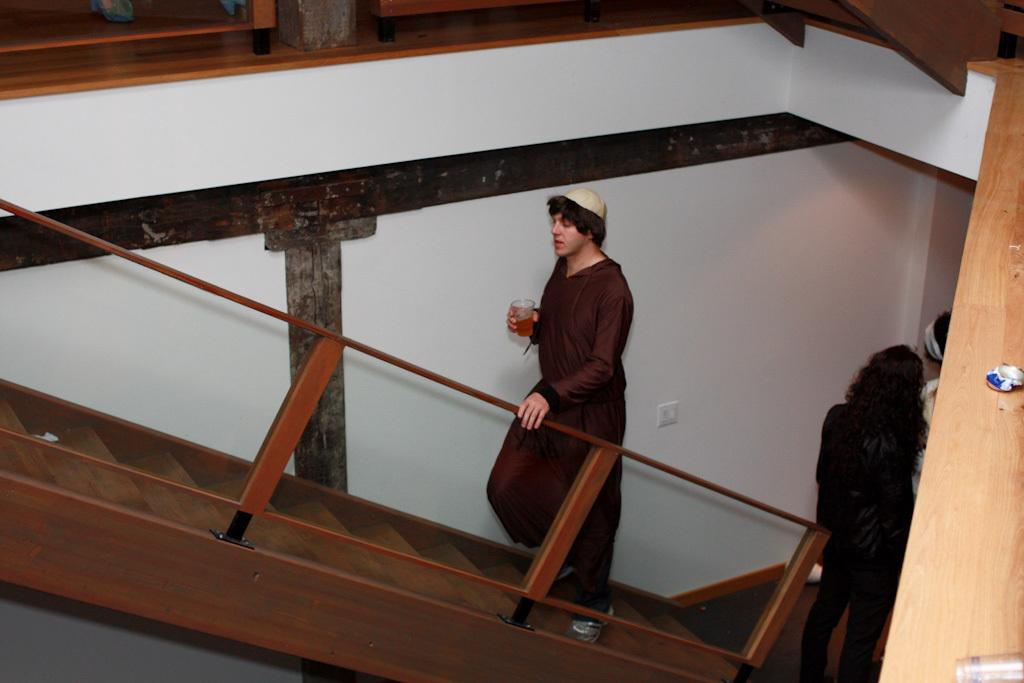How many people are in the image? There are people in the image, but the exact number is not specified. What can be seen in the background of the image? There is a wall in the image, and there are steps and rods visible as well. What is the person holding in the image? One person is holding a glass in the image. What action is the person holding the glass performing? The person holding the glass is climbing the steps in the image. What type of songs can be heard being sung in the lunchroom in the image? There is no mention of a lunchroom or any songs being sung in the image. 